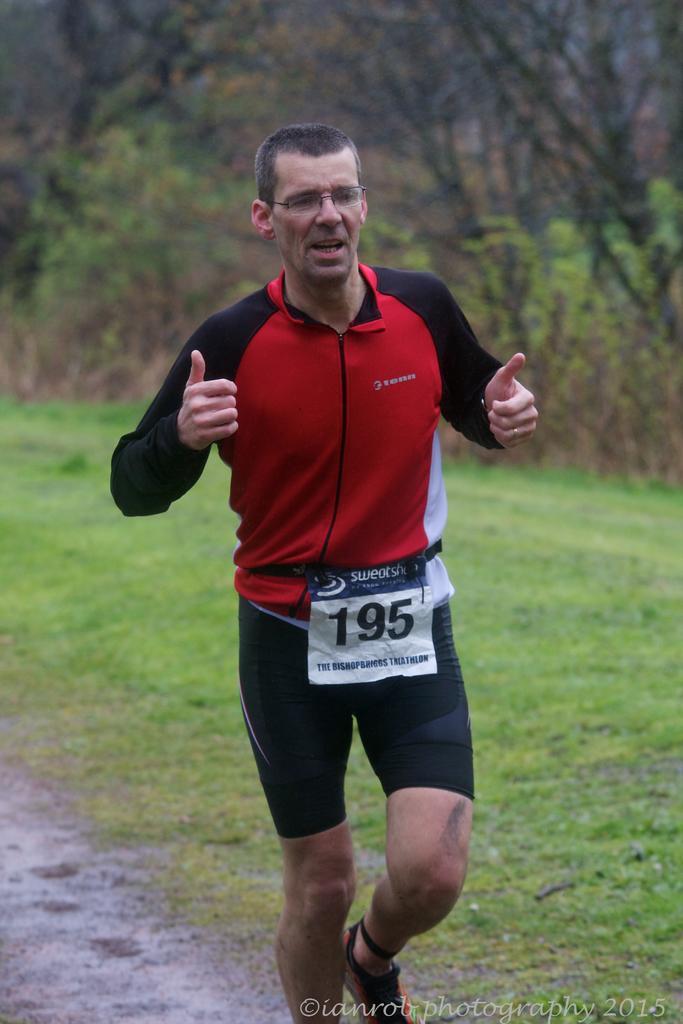How would you summarize this image in a sentence or two? In this image we can see a person wearing specs and chest number. On the ground there is grass. In the background there are trees. In the right bottom corner something is written. 